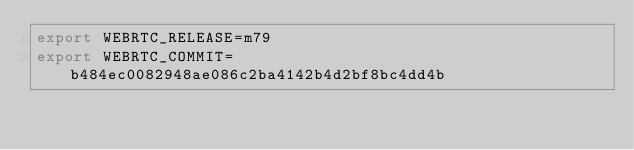<code> <loc_0><loc_0><loc_500><loc_500><_Bash_>export WEBRTC_RELEASE=m79
export WEBRTC_COMMIT=b484ec0082948ae086c2ba4142b4d2bf8bc4dd4b
</code> 